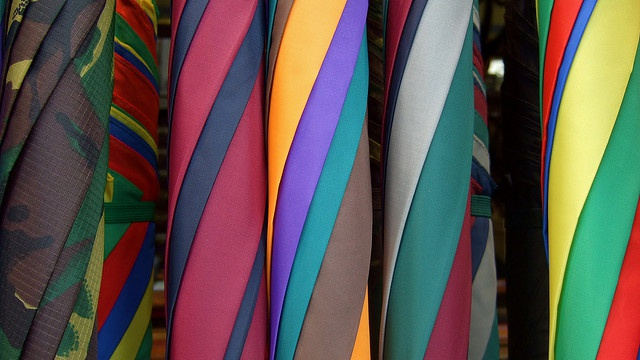Describe the objects in this image and their specific colors. I can see umbrella in teal, black, maroon, gray, and darkgreen tones, umbrella in teal, darkgray, black, and gray tones, umbrella in teal, gray, and magenta tones, umbrella in teal, brown, darkblue, and navy tones, and umbrella in teal, khaki, green, and turquoise tones in this image. 